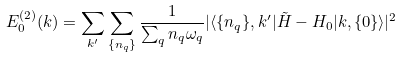<formula> <loc_0><loc_0><loc_500><loc_500>E _ { 0 } ^ { ( 2 ) } ( { k } ) = \sum _ { k ^ { \prime } } \sum _ { \{ n _ { q } \} } \frac { 1 } { \sum _ { q } n _ { q } \omega _ { q } } | \langle \{ n _ { q } \} , { k ^ { \prime } } | \tilde { H } - H _ { 0 } | { k } , \{ 0 \} \rangle | ^ { 2 } \\</formula> 